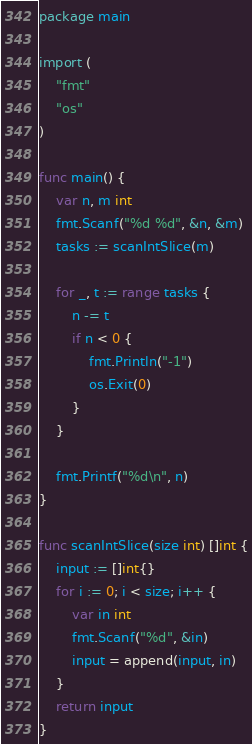Convert code to text. <code><loc_0><loc_0><loc_500><loc_500><_Go_>package main

import (
	"fmt"
	"os"
)

func main() {
	var n, m int
	fmt.Scanf("%d %d", &n, &m)
	tasks := scanIntSlice(m)

	for _, t := range tasks {
		n -= t
		if n < 0 {
			fmt.Println("-1")
			os.Exit(0)
		}
	}

	fmt.Printf("%d\n", n)
}

func scanIntSlice(size int) []int {
	input := []int{}
	for i := 0; i < size; i++ {
		var in int
		fmt.Scanf("%d", &in)
		input = append(input, in)
	}
	return input
}
</code> 